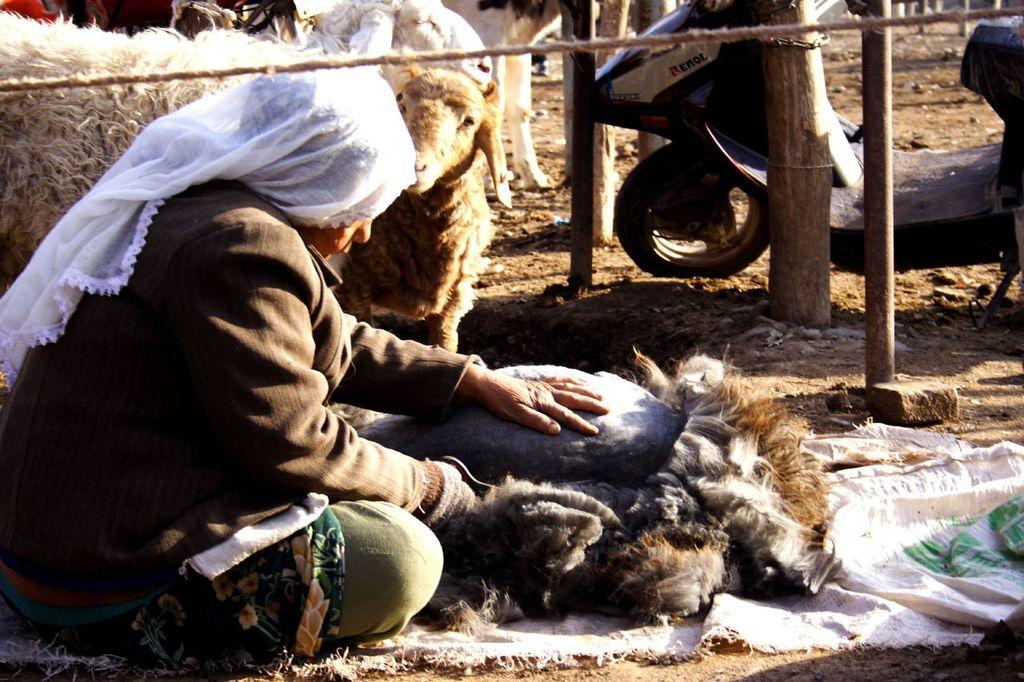What is the person in the image doing? The person is sitting in the image. What is the person wearing? The person is wearing clothes. What type of vehicle is present in the image? There is a two-wheeler in the image. What other living creatures can be seen in the image? There are animals in the image. What objects are present that can be used for tying or securing? There is a rope in the image. What is the tall, upright structure in the image? There is a pole in the image. What type of terrain is visible in the image? There is sand in the image. Can you see a deer flying a plane in the image? No, there is no deer or plane present in the image. 